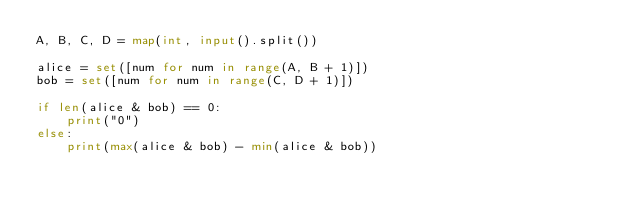<code> <loc_0><loc_0><loc_500><loc_500><_Python_>A, B, C, D = map(int, input().split())

alice = set([num for num in range(A, B + 1)])
bob = set([num for num in range(C, D + 1)])

if len(alice & bob) == 0:
    print("0")
else:
    print(max(alice & bob) - min(alice & bob))
</code> 